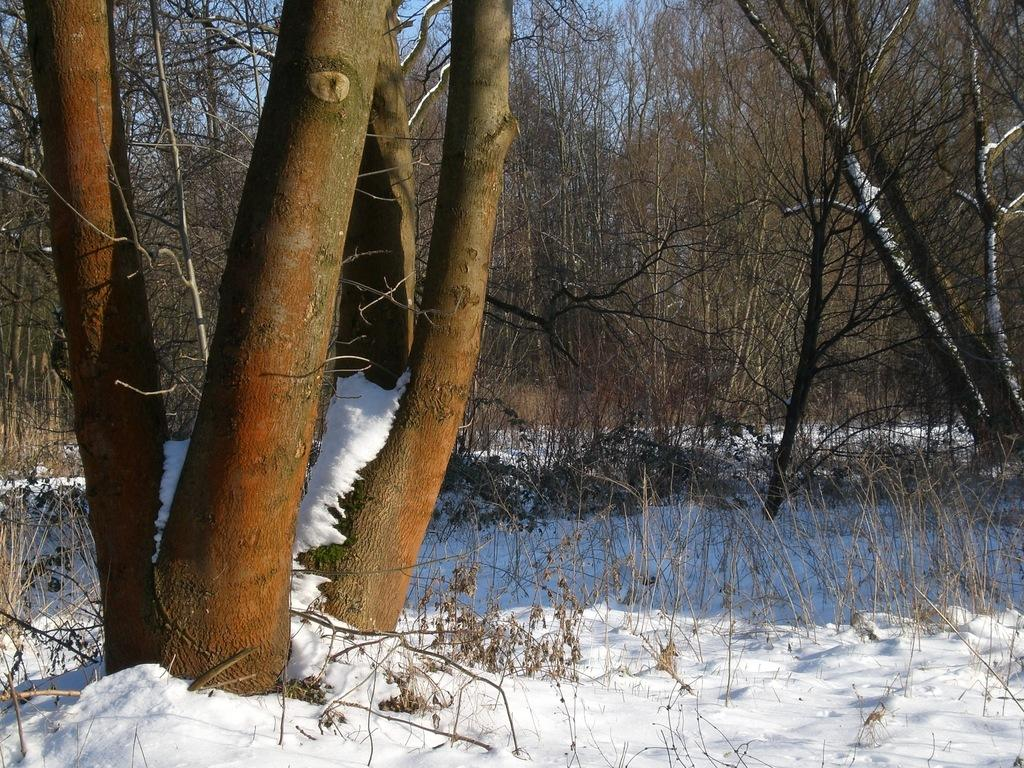What type of trees are in the image? There are dry trees in the image. What is covering the ground in the image? Snow is visible in the image. What part of the natural environment is visible in the image? The sky is visible in the image. What type of vein is visible in the image? There is no vein present in the image; it features dry trees, snow, and the sky. What is the texture of the gun in the image? There is no gun present in the image. 